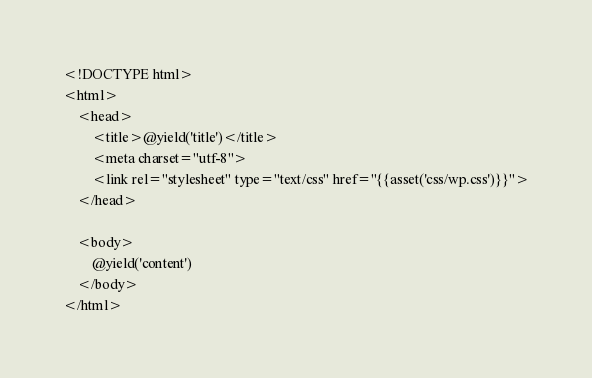Convert code to text. <code><loc_0><loc_0><loc_500><loc_500><_PHP_><!DOCTYPE html>
<html>
    <head>
        <title>@yield('title')</title>
        <meta charset="utf-8">
        <link rel="stylesheet" type="text/css" href="{{asset('css/wp.css')}}">
    </head>

    <body>
        @yield('content')
    </body>
</html></code> 